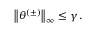<formula> <loc_0><loc_0><loc_500><loc_500>\begin{array} { r } { \left \| \theta ^ { ( \pm ) } \right \| _ { \infty } \leq \gamma \, . } \end{array}</formula> 